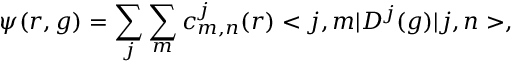Convert formula to latex. <formula><loc_0><loc_0><loc_500><loc_500>\psi ( r , g ) = \sum _ { j } \sum _ { m } c _ { m , n } ^ { j } ( r ) < j , m | D ^ { j } ( g ) | j , n > ,</formula> 